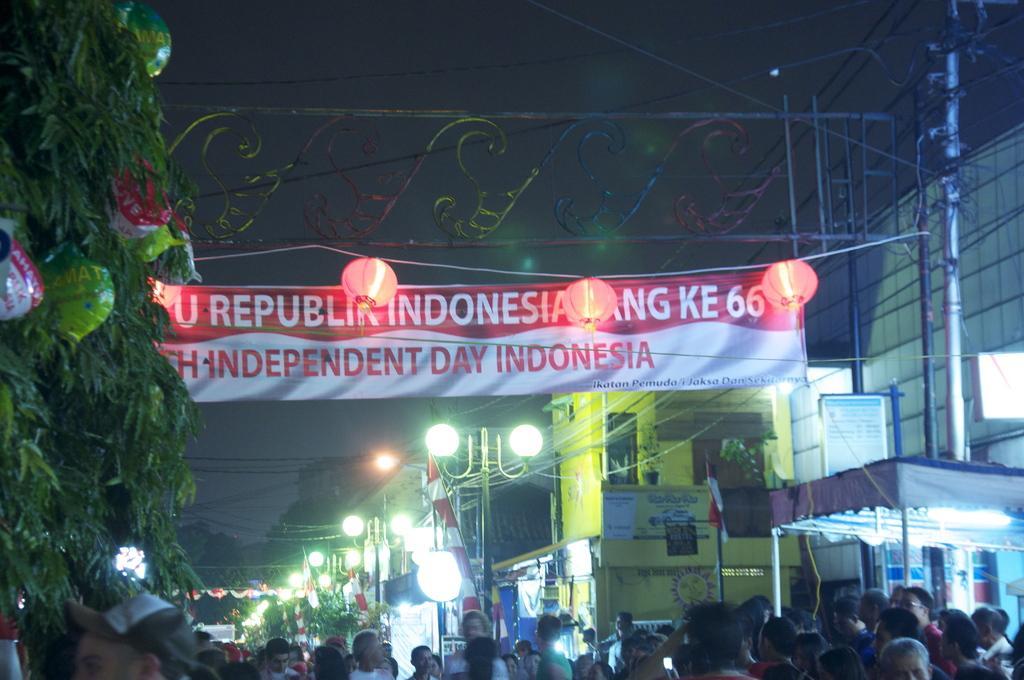Describe this image in one or two sentences. In the image we can see there are people around and wearing clothes. Here we can see a banner and text on it. Here we can see decorative lights, poles and electric wires. Here we can see a light pole, trees and buildings. We can even see a pole tent. 